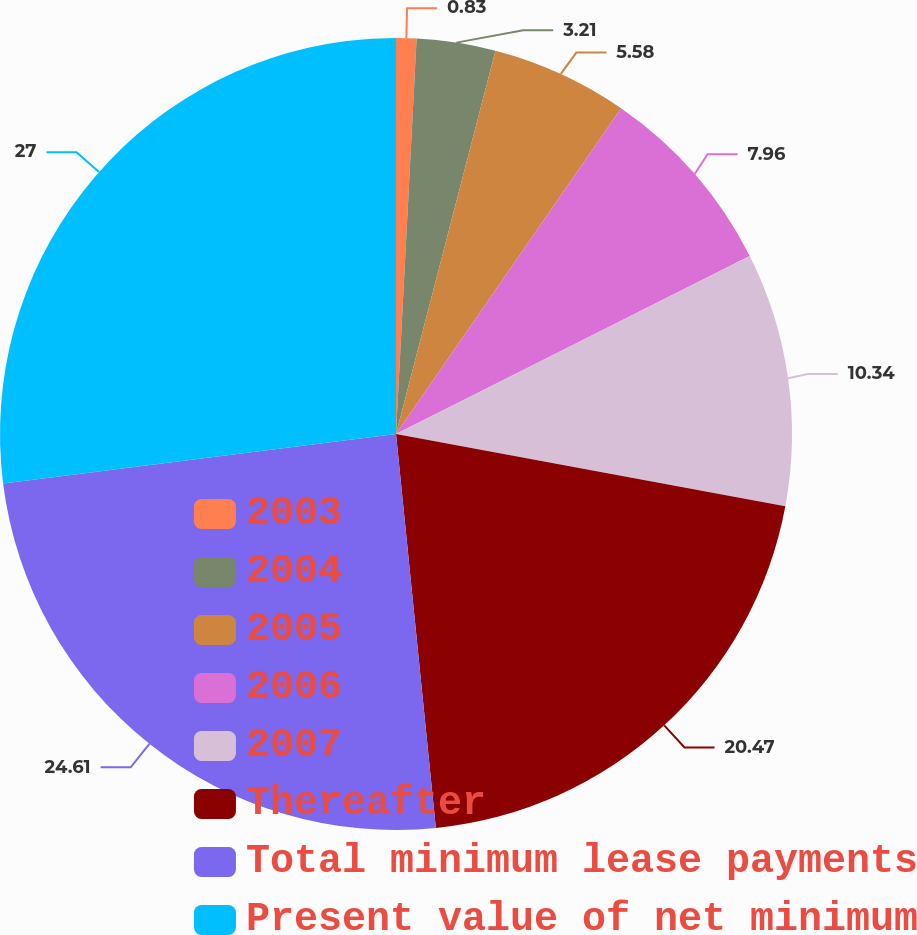Convert chart to OTSL. <chart><loc_0><loc_0><loc_500><loc_500><pie_chart><fcel>2003<fcel>2004<fcel>2005<fcel>2006<fcel>2007<fcel>Thereafter<fcel>Total minimum lease payments<fcel>Present value of net minimum<nl><fcel>0.83%<fcel>3.21%<fcel>5.58%<fcel>7.96%<fcel>10.34%<fcel>20.47%<fcel>24.61%<fcel>26.99%<nl></chart> 